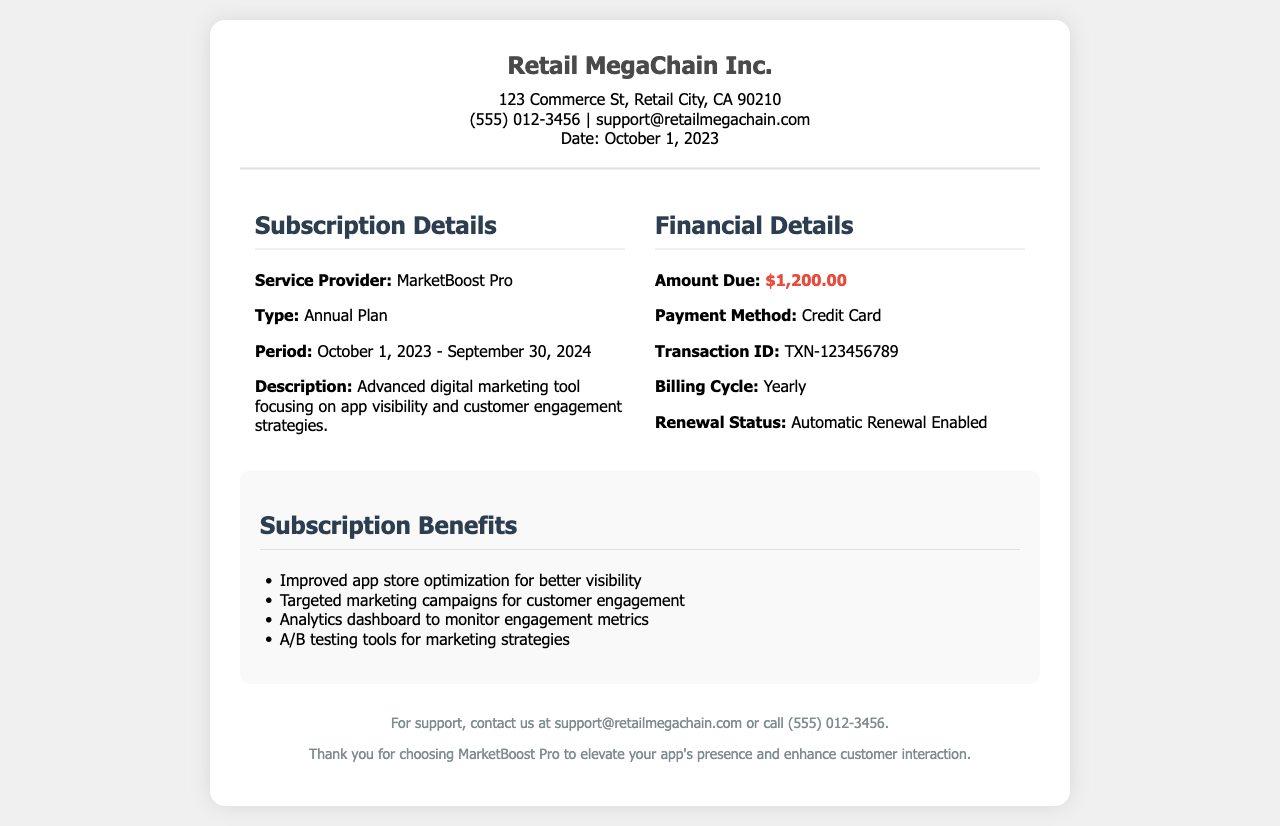what is the service provider? The service provider mentioned in the document is MarketBoost Pro, which is the company offering the digital marketing tool.
Answer: MarketBoost Pro what is the total amount due? The document specifies that the amount due for the subscription renewal is $1,200.00.
Answer: $1,200.00 what is the subscription period? The receipt states that the subscription period runs from October 1, 2023, to September 30, 2024.
Answer: October 1, 2023 - September 30, 2024 what is the payment method? According to the financial details, the payment method used for this transaction is a credit card.
Answer: Credit Card what is the renewal status? The document indicates that the renewal status for this subscription is automatic renewal enabled.
Answer: Automatic Renewal Enabled how many benefits are listed in the document? The receipt lists a total of four subscription benefits related to the service.
Answer: 4 what does the service focus on? The description states that the service focuses on app visibility and customer engagement strategies.
Answer: App visibility and customer engagement what is the transaction ID? The document provides a transaction ID for the payment made, which is TXN-123456789.
Answer: TXN-123456789 who should be contacted for support? The document suggests contacting support through the provided email support@retailmegachain.com or the phone number (555) 012-3456.
Answer: support@retailmegachain.com or (555) 012-3456 